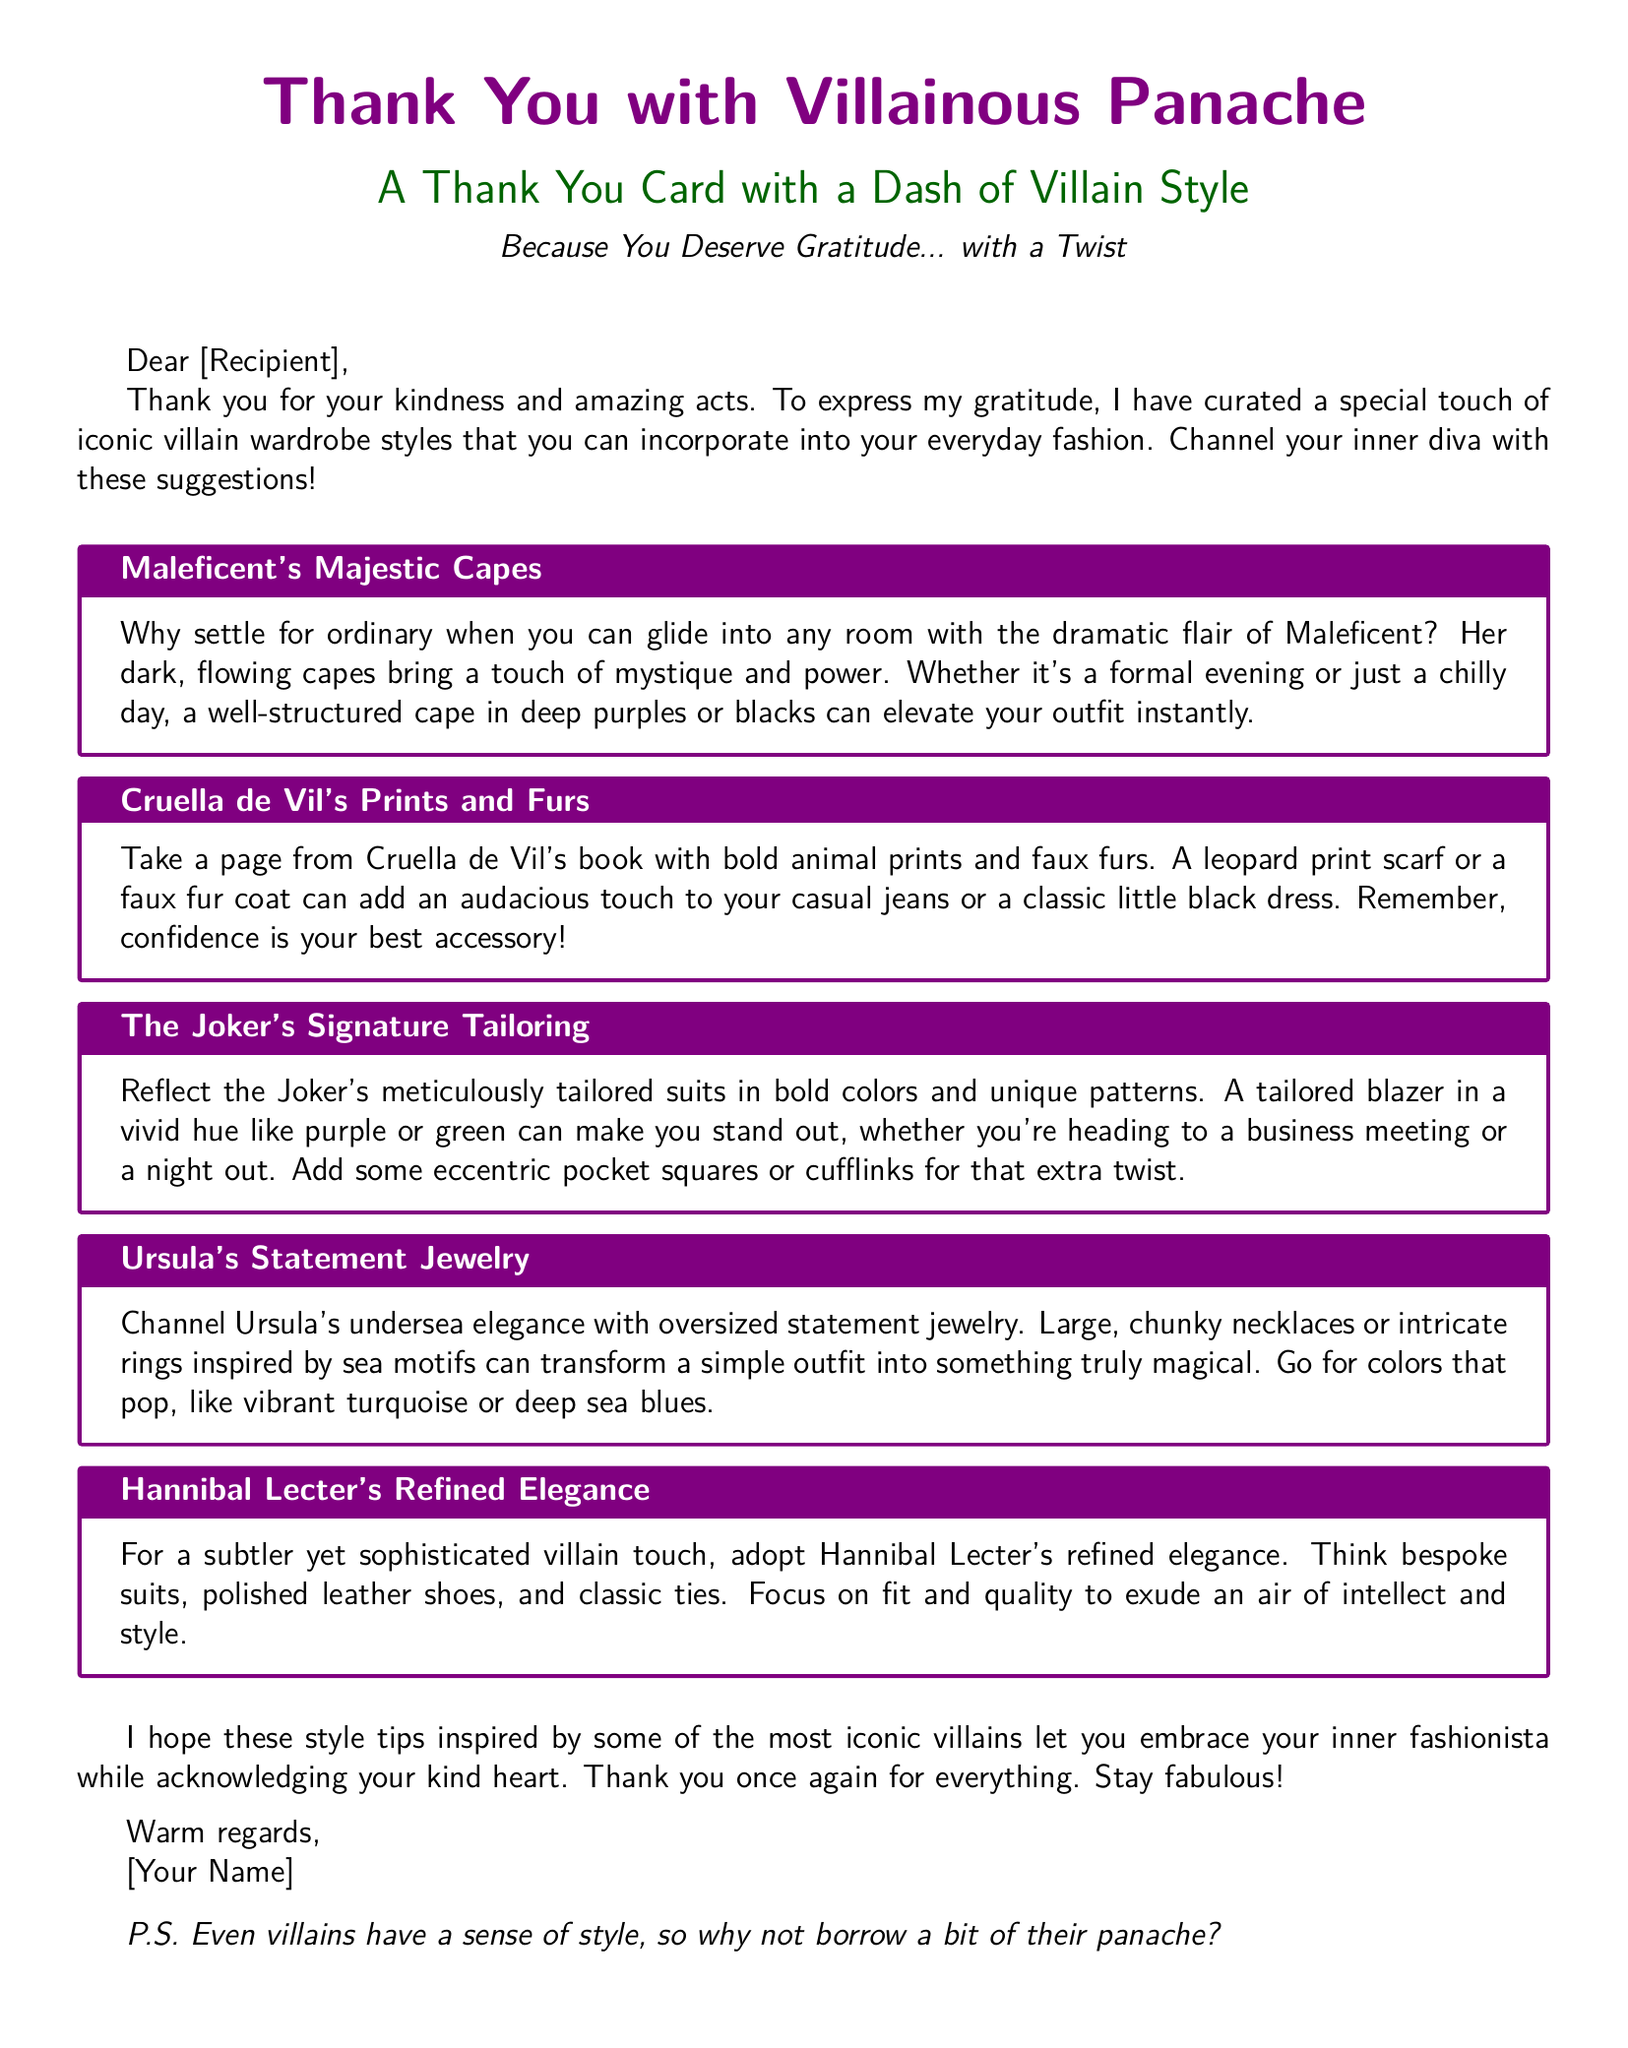What is the main title of the card? The main title appears prominently at the top of the card, stating the theme of the card.
Answer: Thank You with Villainous Panache Who is referenced alongside "refined elegance"? This character is known for their sophistication and a chilling demeanor, used to articulate a style associated with them.
Answer: Hannibal Lecter What is suggested to incorporate into everyday fashion from Maleficent's style? The card highlights the importance of a certain dramatic clothing piece that symbolizes elegance and power.
Answer: Capes Which villain's fashion encourages the use of bold animal prints? This character's style is characterized by a striking pattern associated with a specific animal, promoting audacious choices.
Answer: Cruella de Vil What color is suggested for a tailored blazer inspired by the Joker? The advice points to a vibrant color typically associated with this character's iconic outfits.
Answer: Purple What should one look for in Hannibal Lecter's attire for sophistication? The document emphasizes the importance of a specific aspect of clothing, highlighting the quality and fit associated with elegance.
Answer: Fit and quality How is Ursula's jewelry described in the card? The card mentions a particular style of jewelry that aims to stand out and add flair, characterized by its size and design.
Answer: Statement jewelry What accessory is recommended to complement the Joker's suits? A specific item is recommended to add a unique touch to the tailored look inspired by this character.
Answer: Pocket squares What is the card's overall message towards the recipient? The card conveys a sentiment that encourages embracing a stylish perspective while being grateful.
Answer: Gratitude with a twist 